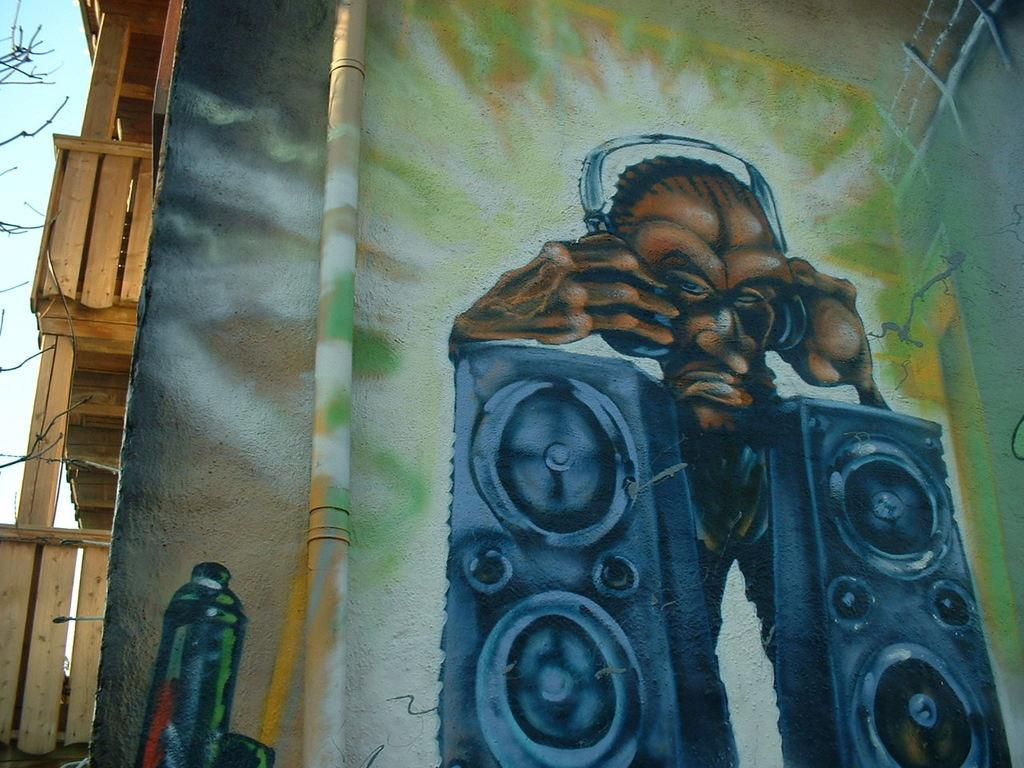What is on the wall in the image? There is graffiti on the wall in the image. What can be seen on the left side of the image? There are wooden planks on the left side of the image. What is visible in the background of the image? The sky is visible in the background of the image. Is there a parcel lying on the grass in the image? There is no grass or parcel present in the image; it only features graffiti on the wall, wooden planks, and the sky in the background. Can you see an orange in the image? There is no orange present in the image. 